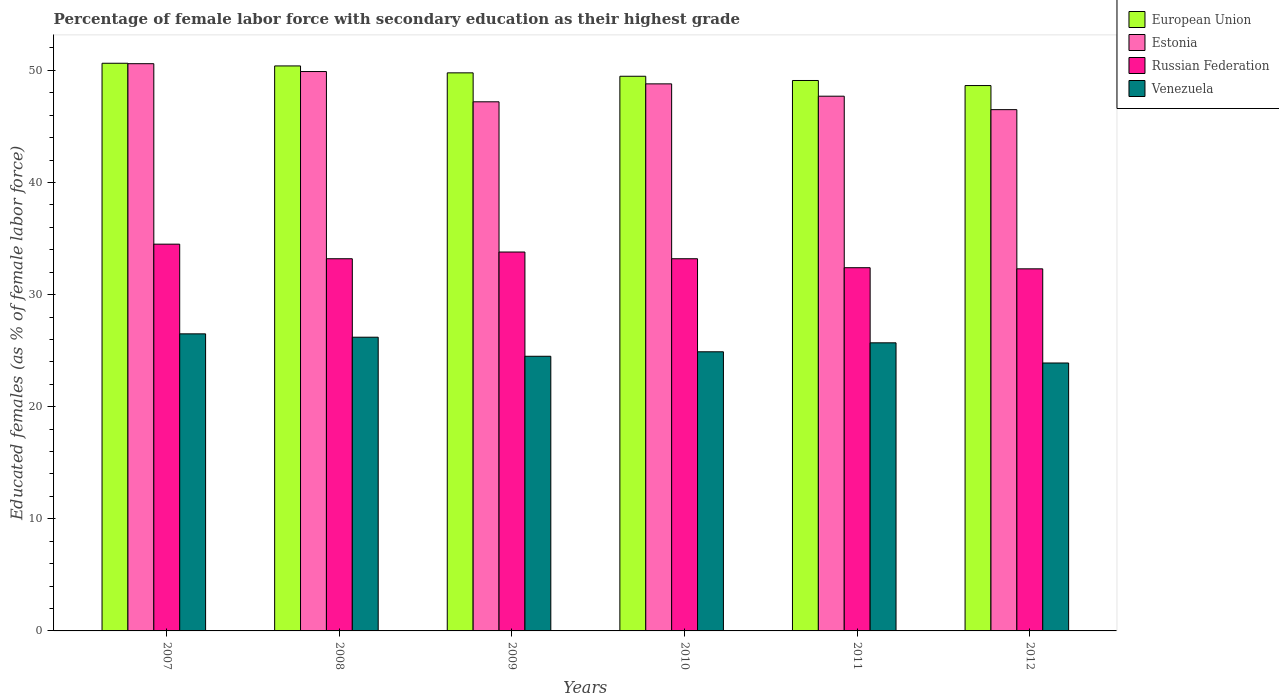How many different coloured bars are there?
Provide a short and direct response. 4. How many groups of bars are there?
Provide a short and direct response. 6. Are the number of bars per tick equal to the number of legend labels?
Your answer should be very brief. Yes. How many bars are there on the 3rd tick from the left?
Your answer should be very brief. 4. What is the label of the 3rd group of bars from the left?
Give a very brief answer. 2009. What is the percentage of female labor force with secondary education in Venezuela in 2009?
Offer a very short reply. 24.5. Across all years, what is the maximum percentage of female labor force with secondary education in European Union?
Offer a very short reply. 50.64. Across all years, what is the minimum percentage of female labor force with secondary education in Venezuela?
Give a very brief answer. 23.9. In which year was the percentage of female labor force with secondary education in Russian Federation maximum?
Ensure brevity in your answer.  2007. In which year was the percentage of female labor force with secondary education in Russian Federation minimum?
Give a very brief answer. 2012. What is the total percentage of female labor force with secondary education in Russian Federation in the graph?
Give a very brief answer. 199.4. What is the difference between the percentage of female labor force with secondary education in European Union in 2008 and that in 2012?
Ensure brevity in your answer.  1.75. What is the difference between the percentage of female labor force with secondary education in Estonia in 2008 and the percentage of female labor force with secondary education in Russian Federation in 2009?
Provide a succinct answer. 16.1. What is the average percentage of female labor force with secondary education in Venezuela per year?
Your response must be concise. 25.28. In the year 2010, what is the difference between the percentage of female labor force with secondary education in European Union and percentage of female labor force with secondary education in Venezuela?
Offer a terse response. 24.58. In how many years, is the percentage of female labor force with secondary education in European Union greater than 24 %?
Ensure brevity in your answer.  6. What is the ratio of the percentage of female labor force with secondary education in Russian Federation in 2009 to that in 2010?
Offer a very short reply. 1.02. Is the percentage of female labor force with secondary education in Venezuela in 2007 less than that in 2011?
Offer a very short reply. No. What is the difference between the highest and the second highest percentage of female labor force with secondary education in Estonia?
Offer a very short reply. 0.7. What is the difference between the highest and the lowest percentage of female labor force with secondary education in European Union?
Ensure brevity in your answer.  1.99. What does the 2nd bar from the left in 2007 represents?
Provide a succinct answer. Estonia. What does the 3rd bar from the right in 2011 represents?
Your response must be concise. Estonia. Is it the case that in every year, the sum of the percentage of female labor force with secondary education in Venezuela and percentage of female labor force with secondary education in European Union is greater than the percentage of female labor force with secondary education in Estonia?
Keep it short and to the point. Yes. How many bars are there?
Provide a succinct answer. 24. Are all the bars in the graph horizontal?
Offer a very short reply. No. How many years are there in the graph?
Your response must be concise. 6. What is the difference between two consecutive major ticks on the Y-axis?
Keep it short and to the point. 10. Does the graph contain any zero values?
Give a very brief answer. No. Does the graph contain grids?
Give a very brief answer. No. How many legend labels are there?
Provide a short and direct response. 4. What is the title of the graph?
Make the answer very short. Percentage of female labor force with secondary education as their highest grade. What is the label or title of the Y-axis?
Your response must be concise. Educated females (as % of female labor force). What is the Educated females (as % of female labor force) of European Union in 2007?
Your answer should be very brief. 50.64. What is the Educated females (as % of female labor force) in Estonia in 2007?
Provide a succinct answer. 50.6. What is the Educated females (as % of female labor force) of Russian Federation in 2007?
Provide a succinct answer. 34.5. What is the Educated females (as % of female labor force) in Venezuela in 2007?
Give a very brief answer. 26.5. What is the Educated females (as % of female labor force) of European Union in 2008?
Offer a terse response. 50.4. What is the Educated females (as % of female labor force) of Estonia in 2008?
Your answer should be compact. 49.9. What is the Educated females (as % of female labor force) in Russian Federation in 2008?
Provide a short and direct response. 33.2. What is the Educated females (as % of female labor force) in Venezuela in 2008?
Provide a short and direct response. 26.2. What is the Educated females (as % of female labor force) in European Union in 2009?
Give a very brief answer. 49.78. What is the Educated females (as % of female labor force) in Estonia in 2009?
Offer a very short reply. 47.2. What is the Educated females (as % of female labor force) of Russian Federation in 2009?
Your response must be concise. 33.8. What is the Educated females (as % of female labor force) of Venezuela in 2009?
Your answer should be compact. 24.5. What is the Educated females (as % of female labor force) of European Union in 2010?
Give a very brief answer. 49.48. What is the Educated females (as % of female labor force) of Estonia in 2010?
Provide a short and direct response. 48.8. What is the Educated females (as % of female labor force) in Russian Federation in 2010?
Provide a short and direct response. 33.2. What is the Educated females (as % of female labor force) of Venezuela in 2010?
Provide a short and direct response. 24.9. What is the Educated females (as % of female labor force) in European Union in 2011?
Offer a very short reply. 49.1. What is the Educated females (as % of female labor force) in Estonia in 2011?
Give a very brief answer. 47.7. What is the Educated females (as % of female labor force) in Russian Federation in 2011?
Give a very brief answer. 32.4. What is the Educated females (as % of female labor force) of Venezuela in 2011?
Offer a very short reply. 25.7. What is the Educated females (as % of female labor force) in European Union in 2012?
Your answer should be compact. 48.65. What is the Educated females (as % of female labor force) of Estonia in 2012?
Offer a terse response. 46.5. What is the Educated females (as % of female labor force) of Russian Federation in 2012?
Provide a succinct answer. 32.3. What is the Educated females (as % of female labor force) in Venezuela in 2012?
Provide a succinct answer. 23.9. Across all years, what is the maximum Educated females (as % of female labor force) in European Union?
Offer a terse response. 50.64. Across all years, what is the maximum Educated females (as % of female labor force) in Estonia?
Keep it short and to the point. 50.6. Across all years, what is the maximum Educated females (as % of female labor force) of Russian Federation?
Offer a terse response. 34.5. Across all years, what is the maximum Educated females (as % of female labor force) in Venezuela?
Give a very brief answer. 26.5. Across all years, what is the minimum Educated females (as % of female labor force) of European Union?
Your response must be concise. 48.65. Across all years, what is the minimum Educated females (as % of female labor force) in Estonia?
Give a very brief answer. 46.5. Across all years, what is the minimum Educated females (as % of female labor force) of Russian Federation?
Provide a short and direct response. 32.3. Across all years, what is the minimum Educated females (as % of female labor force) in Venezuela?
Your answer should be very brief. 23.9. What is the total Educated females (as % of female labor force) of European Union in the graph?
Provide a short and direct response. 298.05. What is the total Educated females (as % of female labor force) of Estonia in the graph?
Make the answer very short. 290.7. What is the total Educated females (as % of female labor force) of Russian Federation in the graph?
Provide a short and direct response. 199.4. What is the total Educated females (as % of female labor force) in Venezuela in the graph?
Your answer should be compact. 151.7. What is the difference between the Educated females (as % of female labor force) of European Union in 2007 and that in 2008?
Provide a short and direct response. 0.24. What is the difference between the Educated females (as % of female labor force) in Russian Federation in 2007 and that in 2008?
Keep it short and to the point. 1.3. What is the difference between the Educated females (as % of female labor force) in European Union in 2007 and that in 2009?
Your answer should be very brief. 0.86. What is the difference between the Educated females (as % of female labor force) in Venezuela in 2007 and that in 2009?
Provide a succinct answer. 2. What is the difference between the Educated females (as % of female labor force) in European Union in 2007 and that in 2010?
Your response must be concise. 1.16. What is the difference between the Educated females (as % of female labor force) in Estonia in 2007 and that in 2010?
Your answer should be compact. 1.8. What is the difference between the Educated females (as % of female labor force) in Russian Federation in 2007 and that in 2010?
Provide a short and direct response. 1.3. What is the difference between the Educated females (as % of female labor force) in European Union in 2007 and that in 2011?
Your response must be concise. 1.54. What is the difference between the Educated females (as % of female labor force) in Estonia in 2007 and that in 2011?
Make the answer very short. 2.9. What is the difference between the Educated females (as % of female labor force) in European Union in 2007 and that in 2012?
Make the answer very short. 1.99. What is the difference between the Educated females (as % of female labor force) in Estonia in 2007 and that in 2012?
Give a very brief answer. 4.1. What is the difference between the Educated females (as % of female labor force) of Russian Federation in 2007 and that in 2012?
Provide a short and direct response. 2.2. What is the difference between the Educated females (as % of female labor force) in European Union in 2008 and that in 2009?
Your response must be concise. 0.62. What is the difference between the Educated females (as % of female labor force) in Russian Federation in 2008 and that in 2009?
Provide a short and direct response. -0.6. What is the difference between the Educated females (as % of female labor force) in Venezuela in 2008 and that in 2009?
Make the answer very short. 1.7. What is the difference between the Educated females (as % of female labor force) in European Union in 2008 and that in 2010?
Offer a very short reply. 0.92. What is the difference between the Educated females (as % of female labor force) of Venezuela in 2008 and that in 2010?
Keep it short and to the point. 1.3. What is the difference between the Educated females (as % of female labor force) in European Union in 2008 and that in 2011?
Keep it short and to the point. 1.3. What is the difference between the Educated females (as % of female labor force) in Estonia in 2008 and that in 2011?
Make the answer very short. 2.2. What is the difference between the Educated females (as % of female labor force) of Venezuela in 2008 and that in 2011?
Keep it short and to the point. 0.5. What is the difference between the Educated females (as % of female labor force) in European Union in 2008 and that in 2012?
Ensure brevity in your answer.  1.75. What is the difference between the Educated females (as % of female labor force) in Russian Federation in 2008 and that in 2012?
Keep it short and to the point. 0.9. What is the difference between the Educated females (as % of female labor force) in Venezuela in 2008 and that in 2012?
Make the answer very short. 2.3. What is the difference between the Educated females (as % of female labor force) in European Union in 2009 and that in 2010?
Offer a terse response. 0.3. What is the difference between the Educated females (as % of female labor force) of Estonia in 2009 and that in 2010?
Your answer should be compact. -1.6. What is the difference between the Educated females (as % of female labor force) in Venezuela in 2009 and that in 2010?
Your answer should be compact. -0.4. What is the difference between the Educated females (as % of female labor force) in European Union in 2009 and that in 2011?
Make the answer very short. 0.68. What is the difference between the Educated females (as % of female labor force) in Venezuela in 2009 and that in 2011?
Keep it short and to the point. -1.2. What is the difference between the Educated females (as % of female labor force) of European Union in 2009 and that in 2012?
Provide a short and direct response. 1.13. What is the difference between the Educated females (as % of female labor force) in Estonia in 2009 and that in 2012?
Provide a succinct answer. 0.7. What is the difference between the Educated females (as % of female labor force) of European Union in 2010 and that in 2011?
Keep it short and to the point. 0.38. What is the difference between the Educated females (as % of female labor force) of European Union in 2010 and that in 2012?
Make the answer very short. 0.83. What is the difference between the Educated females (as % of female labor force) of European Union in 2011 and that in 2012?
Keep it short and to the point. 0.45. What is the difference between the Educated females (as % of female labor force) in Russian Federation in 2011 and that in 2012?
Provide a succinct answer. 0.1. What is the difference between the Educated females (as % of female labor force) in European Union in 2007 and the Educated females (as % of female labor force) in Estonia in 2008?
Your answer should be compact. 0.74. What is the difference between the Educated females (as % of female labor force) of European Union in 2007 and the Educated females (as % of female labor force) of Russian Federation in 2008?
Provide a succinct answer. 17.44. What is the difference between the Educated females (as % of female labor force) of European Union in 2007 and the Educated females (as % of female labor force) of Venezuela in 2008?
Provide a succinct answer. 24.44. What is the difference between the Educated females (as % of female labor force) in Estonia in 2007 and the Educated females (as % of female labor force) in Russian Federation in 2008?
Your answer should be compact. 17.4. What is the difference between the Educated females (as % of female labor force) in Estonia in 2007 and the Educated females (as % of female labor force) in Venezuela in 2008?
Provide a short and direct response. 24.4. What is the difference between the Educated females (as % of female labor force) in Russian Federation in 2007 and the Educated females (as % of female labor force) in Venezuela in 2008?
Your answer should be compact. 8.3. What is the difference between the Educated females (as % of female labor force) of European Union in 2007 and the Educated females (as % of female labor force) of Estonia in 2009?
Your answer should be very brief. 3.44. What is the difference between the Educated females (as % of female labor force) of European Union in 2007 and the Educated females (as % of female labor force) of Russian Federation in 2009?
Offer a terse response. 16.84. What is the difference between the Educated females (as % of female labor force) in European Union in 2007 and the Educated females (as % of female labor force) in Venezuela in 2009?
Ensure brevity in your answer.  26.14. What is the difference between the Educated females (as % of female labor force) in Estonia in 2007 and the Educated females (as % of female labor force) in Venezuela in 2009?
Your response must be concise. 26.1. What is the difference between the Educated females (as % of female labor force) in Russian Federation in 2007 and the Educated females (as % of female labor force) in Venezuela in 2009?
Give a very brief answer. 10. What is the difference between the Educated females (as % of female labor force) of European Union in 2007 and the Educated females (as % of female labor force) of Estonia in 2010?
Give a very brief answer. 1.84. What is the difference between the Educated females (as % of female labor force) of European Union in 2007 and the Educated females (as % of female labor force) of Russian Federation in 2010?
Your answer should be compact. 17.44. What is the difference between the Educated females (as % of female labor force) of European Union in 2007 and the Educated females (as % of female labor force) of Venezuela in 2010?
Provide a succinct answer. 25.74. What is the difference between the Educated females (as % of female labor force) of Estonia in 2007 and the Educated females (as % of female labor force) of Venezuela in 2010?
Your response must be concise. 25.7. What is the difference between the Educated females (as % of female labor force) of Russian Federation in 2007 and the Educated females (as % of female labor force) of Venezuela in 2010?
Your response must be concise. 9.6. What is the difference between the Educated females (as % of female labor force) of European Union in 2007 and the Educated females (as % of female labor force) of Estonia in 2011?
Your answer should be compact. 2.94. What is the difference between the Educated females (as % of female labor force) in European Union in 2007 and the Educated females (as % of female labor force) in Russian Federation in 2011?
Your response must be concise. 18.24. What is the difference between the Educated females (as % of female labor force) in European Union in 2007 and the Educated females (as % of female labor force) in Venezuela in 2011?
Offer a very short reply. 24.94. What is the difference between the Educated females (as % of female labor force) in Estonia in 2007 and the Educated females (as % of female labor force) in Russian Federation in 2011?
Keep it short and to the point. 18.2. What is the difference between the Educated females (as % of female labor force) in Estonia in 2007 and the Educated females (as % of female labor force) in Venezuela in 2011?
Provide a short and direct response. 24.9. What is the difference between the Educated females (as % of female labor force) of European Union in 2007 and the Educated females (as % of female labor force) of Estonia in 2012?
Provide a succinct answer. 4.14. What is the difference between the Educated females (as % of female labor force) in European Union in 2007 and the Educated females (as % of female labor force) in Russian Federation in 2012?
Your answer should be compact. 18.34. What is the difference between the Educated females (as % of female labor force) in European Union in 2007 and the Educated females (as % of female labor force) in Venezuela in 2012?
Your response must be concise. 26.74. What is the difference between the Educated females (as % of female labor force) in Estonia in 2007 and the Educated females (as % of female labor force) in Venezuela in 2012?
Provide a succinct answer. 26.7. What is the difference between the Educated females (as % of female labor force) in European Union in 2008 and the Educated females (as % of female labor force) in Venezuela in 2009?
Your answer should be very brief. 25.9. What is the difference between the Educated females (as % of female labor force) of Estonia in 2008 and the Educated females (as % of female labor force) of Venezuela in 2009?
Ensure brevity in your answer.  25.4. What is the difference between the Educated females (as % of female labor force) of Russian Federation in 2008 and the Educated females (as % of female labor force) of Venezuela in 2009?
Provide a succinct answer. 8.7. What is the difference between the Educated females (as % of female labor force) of European Union in 2008 and the Educated females (as % of female labor force) of Estonia in 2010?
Offer a very short reply. 1.6. What is the difference between the Educated females (as % of female labor force) in European Union in 2008 and the Educated females (as % of female labor force) in Russian Federation in 2010?
Provide a short and direct response. 17.2. What is the difference between the Educated females (as % of female labor force) of European Union in 2008 and the Educated females (as % of female labor force) of Venezuela in 2010?
Your answer should be very brief. 25.5. What is the difference between the Educated females (as % of female labor force) in European Union in 2008 and the Educated females (as % of female labor force) in Venezuela in 2011?
Your response must be concise. 24.7. What is the difference between the Educated females (as % of female labor force) in Estonia in 2008 and the Educated females (as % of female labor force) in Venezuela in 2011?
Your answer should be compact. 24.2. What is the difference between the Educated females (as % of female labor force) in Russian Federation in 2008 and the Educated females (as % of female labor force) in Venezuela in 2011?
Your response must be concise. 7.5. What is the difference between the Educated females (as % of female labor force) of European Union in 2008 and the Educated females (as % of female labor force) of Estonia in 2012?
Offer a terse response. 3.9. What is the difference between the Educated females (as % of female labor force) of European Union in 2008 and the Educated females (as % of female labor force) of Russian Federation in 2012?
Give a very brief answer. 18.1. What is the difference between the Educated females (as % of female labor force) of Estonia in 2008 and the Educated females (as % of female labor force) of Russian Federation in 2012?
Your answer should be very brief. 17.6. What is the difference between the Educated females (as % of female labor force) of Russian Federation in 2008 and the Educated females (as % of female labor force) of Venezuela in 2012?
Offer a very short reply. 9.3. What is the difference between the Educated females (as % of female labor force) in European Union in 2009 and the Educated females (as % of female labor force) in Estonia in 2010?
Offer a terse response. 0.98. What is the difference between the Educated females (as % of female labor force) of European Union in 2009 and the Educated females (as % of female labor force) of Russian Federation in 2010?
Give a very brief answer. 16.58. What is the difference between the Educated females (as % of female labor force) of European Union in 2009 and the Educated females (as % of female labor force) of Venezuela in 2010?
Provide a short and direct response. 24.88. What is the difference between the Educated females (as % of female labor force) in Estonia in 2009 and the Educated females (as % of female labor force) in Russian Federation in 2010?
Keep it short and to the point. 14. What is the difference between the Educated females (as % of female labor force) in Estonia in 2009 and the Educated females (as % of female labor force) in Venezuela in 2010?
Provide a short and direct response. 22.3. What is the difference between the Educated females (as % of female labor force) of European Union in 2009 and the Educated females (as % of female labor force) of Estonia in 2011?
Offer a very short reply. 2.08. What is the difference between the Educated females (as % of female labor force) of European Union in 2009 and the Educated females (as % of female labor force) of Russian Federation in 2011?
Ensure brevity in your answer.  17.38. What is the difference between the Educated females (as % of female labor force) in European Union in 2009 and the Educated females (as % of female labor force) in Venezuela in 2011?
Ensure brevity in your answer.  24.08. What is the difference between the Educated females (as % of female labor force) of Estonia in 2009 and the Educated females (as % of female labor force) of Venezuela in 2011?
Offer a terse response. 21.5. What is the difference between the Educated females (as % of female labor force) in Russian Federation in 2009 and the Educated females (as % of female labor force) in Venezuela in 2011?
Offer a terse response. 8.1. What is the difference between the Educated females (as % of female labor force) of European Union in 2009 and the Educated females (as % of female labor force) of Estonia in 2012?
Provide a short and direct response. 3.28. What is the difference between the Educated females (as % of female labor force) in European Union in 2009 and the Educated females (as % of female labor force) in Russian Federation in 2012?
Your response must be concise. 17.48. What is the difference between the Educated females (as % of female labor force) of European Union in 2009 and the Educated females (as % of female labor force) of Venezuela in 2012?
Ensure brevity in your answer.  25.88. What is the difference between the Educated females (as % of female labor force) of Estonia in 2009 and the Educated females (as % of female labor force) of Venezuela in 2012?
Provide a short and direct response. 23.3. What is the difference between the Educated females (as % of female labor force) of Russian Federation in 2009 and the Educated females (as % of female labor force) of Venezuela in 2012?
Provide a succinct answer. 9.9. What is the difference between the Educated females (as % of female labor force) of European Union in 2010 and the Educated females (as % of female labor force) of Estonia in 2011?
Ensure brevity in your answer.  1.78. What is the difference between the Educated females (as % of female labor force) of European Union in 2010 and the Educated females (as % of female labor force) of Russian Federation in 2011?
Make the answer very short. 17.08. What is the difference between the Educated females (as % of female labor force) in European Union in 2010 and the Educated females (as % of female labor force) in Venezuela in 2011?
Give a very brief answer. 23.78. What is the difference between the Educated females (as % of female labor force) in Estonia in 2010 and the Educated females (as % of female labor force) in Venezuela in 2011?
Offer a very short reply. 23.1. What is the difference between the Educated females (as % of female labor force) of Russian Federation in 2010 and the Educated females (as % of female labor force) of Venezuela in 2011?
Your answer should be compact. 7.5. What is the difference between the Educated females (as % of female labor force) of European Union in 2010 and the Educated females (as % of female labor force) of Estonia in 2012?
Provide a short and direct response. 2.98. What is the difference between the Educated females (as % of female labor force) of European Union in 2010 and the Educated females (as % of female labor force) of Russian Federation in 2012?
Your response must be concise. 17.18. What is the difference between the Educated females (as % of female labor force) in European Union in 2010 and the Educated females (as % of female labor force) in Venezuela in 2012?
Keep it short and to the point. 25.58. What is the difference between the Educated females (as % of female labor force) of Estonia in 2010 and the Educated females (as % of female labor force) of Russian Federation in 2012?
Keep it short and to the point. 16.5. What is the difference between the Educated females (as % of female labor force) in Estonia in 2010 and the Educated females (as % of female labor force) in Venezuela in 2012?
Offer a terse response. 24.9. What is the difference between the Educated females (as % of female labor force) in Russian Federation in 2010 and the Educated females (as % of female labor force) in Venezuela in 2012?
Offer a terse response. 9.3. What is the difference between the Educated females (as % of female labor force) in European Union in 2011 and the Educated females (as % of female labor force) in Estonia in 2012?
Your answer should be compact. 2.6. What is the difference between the Educated females (as % of female labor force) in European Union in 2011 and the Educated females (as % of female labor force) in Russian Federation in 2012?
Offer a very short reply. 16.8. What is the difference between the Educated females (as % of female labor force) in European Union in 2011 and the Educated females (as % of female labor force) in Venezuela in 2012?
Offer a very short reply. 25.2. What is the difference between the Educated females (as % of female labor force) of Estonia in 2011 and the Educated females (as % of female labor force) of Russian Federation in 2012?
Make the answer very short. 15.4. What is the difference between the Educated females (as % of female labor force) in Estonia in 2011 and the Educated females (as % of female labor force) in Venezuela in 2012?
Keep it short and to the point. 23.8. What is the average Educated females (as % of female labor force) of European Union per year?
Make the answer very short. 49.67. What is the average Educated females (as % of female labor force) in Estonia per year?
Offer a very short reply. 48.45. What is the average Educated females (as % of female labor force) of Russian Federation per year?
Ensure brevity in your answer.  33.23. What is the average Educated females (as % of female labor force) in Venezuela per year?
Offer a terse response. 25.28. In the year 2007, what is the difference between the Educated females (as % of female labor force) of European Union and Educated females (as % of female labor force) of Estonia?
Offer a terse response. 0.04. In the year 2007, what is the difference between the Educated females (as % of female labor force) of European Union and Educated females (as % of female labor force) of Russian Federation?
Give a very brief answer. 16.14. In the year 2007, what is the difference between the Educated females (as % of female labor force) in European Union and Educated females (as % of female labor force) in Venezuela?
Ensure brevity in your answer.  24.14. In the year 2007, what is the difference between the Educated females (as % of female labor force) of Estonia and Educated females (as % of female labor force) of Venezuela?
Ensure brevity in your answer.  24.1. In the year 2007, what is the difference between the Educated females (as % of female labor force) of Russian Federation and Educated females (as % of female labor force) of Venezuela?
Provide a succinct answer. 8. In the year 2008, what is the difference between the Educated females (as % of female labor force) in European Union and Educated females (as % of female labor force) in Russian Federation?
Provide a succinct answer. 17.2. In the year 2008, what is the difference between the Educated females (as % of female labor force) in European Union and Educated females (as % of female labor force) in Venezuela?
Offer a very short reply. 24.2. In the year 2008, what is the difference between the Educated females (as % of female labor force) in Estonia and Educated females (as % of female labor force) in Venezuela?
Offer a very short reply. 23.7. In the year 2008, what is the difference between the Educated females (as % of female labor force) of Russian Federation and Educated females (as % of female labor force) of Venezuela?
Provide a short and direct response. 7. In the year 2009, what is the difference between the Educated females (as % of female labor force) of European Union and Educated females (as % of female labor force) of Estonia?
Offer a terse response. 2.58. In the year 2009, what is the difference between the Educated females (as % of female labor force) of European Union and Educated females (as % of female labor force) of Russian Federation?
Ensure brevity in your answer.  15.98. In the year 2009, what is the difference between the Educated females (as % of female labor force) in European Union and Educated females (as % of female labor force) in Venezuela?
Your answer should be compact. 25.28. In the year 2009, what is the difference between the Educated females (as % of female labor force) in Estonia and Educated females (as % of female labor force) in Russian Federation?
Give a very brief answer. 13.4. In the year 2009, what is the difference between the Educated females (as % of female labor force) in Estonia and Educated females (as % of female labor force) in Venezuela?
Ensure brevity in your answer.  22.7. In the year 2010, what is the difference between the Educated females (as % of female labor force) of European Union and Educated females (as % of female labor force) of Estonia?
Keep it short and to the point. 0.68. In the year 2010, what is the difference between the Educated females (as % of female labor force) in European Union and Educated females (as % of female labor force) in Russian Federation?
Make the answer very short. 16.28. In the year 2010, what is the difference between the Educated females (as % of female labor force) in European Union and Educated females (as % of female labor force) in Venezuela?
Your answer should be very brief. 24.58. In the year 2010, what is the difference between the Educated females (as % of female labor force) in Estonia and Educated females (as % of female labor force) in Russian Federation?
Your response must be concise. 15.6. In the year 2010, what is the difference between the Educated females (as % of female labor force) of Estonia and Educated females (as % of female labor force) of Venezuela?
Ensure brevity in your answer.  23.9. In the year 2010, what is the difference between the Educated females (as % of female labor force) of Russian Federation and Educated females (as % of female labor force) of Venezuela?
Your response must be concise. 8.3. In the year 2011, what is the difference between the Educated females (as % of female labor force) of European Union and Educated females (as % of female labor force) of Estonia?
Make the answer very short. 1.4. In the year 2011, what is the difference between the Educated females (as % of female labor force) in European Union and Educated females (as % of female labor force) in Russian Federation?
Provide a succinct answer. 16.7. In the year 2011, what is the difference between the Educated females (as % of female labor force) in European Union and Educated females (as % of female labor force) in Venezuela?
Ensure brevity in your answer.  23.4. In the year 2011, what is the difference between the Educated females (as % of female labor force) of Estonia and Educated females (as % of female labor force) of Venezuela?
Your response must be concise. 22. In the year 2011, what is the difference between the Educated females (as % of female labor force) of Russian Federation and Educated females (as % of female labor force) of Venezuela?
Give a very brief answer. 6.7. In the year 2012, what is the difference between the Educated females (as % of female labor force) of European Union and Educated females (as % of female labor force) of Estonia?
Ensure brevity in your answer.  2.15. In the year 2012, what is the difference between the Educated females (as % of female labor force) in European Union and Educated females (as % of female labor force) in Russian Federation?
Keep it short and to the point. 16.35. In the year 2012, what is the difference between the Educated females (as % of female labor force) in European Union and Educated females (as % of female labor force) in Venezuela?
Your response must be concise. 24.75. In the year 2012, what is the difference between the Educated females (as % of female labor force) in Estonia and Educated females (as % of female labor force) in Venezuela?
Your response must be concise. 22.6. In the year 2012, what is the difference between the Educated females (as % of female labor force) of Russian Federation and Educated females (as % of female labor force) of Venezuela?
Your answer should be compact. 8.4. What is the ratio of the Educated females (as % of female labor force) in European Union in 2007 to that in 2008?
Offer a very short reply. 1. What is the ratio of the Educated females (as % of female labor force) of Estonia in 2007 to that in 2008?
Your answer should be compact. 1.01. What is the ratio of the Educated females (as % of female labor force) in Russian Federation in 2007 to that in 2008?
Your answer should be very brief. 1.04. What is the ratio of the Educated females (as % of female labor force) of Venezuela in 2007 to that in 2008?
Your response must be concise. 1.01. What is the ratio of the Educated females (as % of female labor force) in European Union in 2007 to that in 2009?
Make the answer very short. 1.02. What is the ratio of the Educated females (as % of female labor force) in Estonia in 2007 to that in 2009?
Make the answer very short. 1.07. What is the ratio of the Educated females (as % of female labor force) in Russian Federation in 2007 to that in 2009?
Keep it short and to the point. 1.02. What is the ratio of the Educated females (as % of female labor force) of Venezuela in 2007 to that in 2009?
Provide a succinct answer. 1.08. What is the ratio of the Educated females (as % of female labor force) of European Union in 2007 to that in 2010?
Provide a short and direct response. 1.02. What is the ratio of the Educated females (as % of female labor force) of Estonia in 2007 to that in 2010?
Make the answer very short. 1.04. What is the ratio of the Educated females (as % of female labor force) in Russian Federation in 2007 to that in 2010?
Offer a terse response. 1.04. What is the ratio of the Educated females (as % of female labor force) in Venezuela in 2007 to that in 2010?
Provide a short and direct response. 1.06. What is the ratio of the Educated females (as % of female labor force) in European Union in 2007 to that in 2011?
Give a very brief answer. 1.03. What is the ratio of the Educated females (as % of female labor force) in Estonia in 2007 to that in 2011?
Your answer should be very brief. 1.06. What is the ratio of the Educated females (as % of female labor force) in Russian Federation in 2007 to that in 2011?
Give a very brief answer. 1.06. What is the ratio of the Educated females (as % of female labor force) of Venezuela in 2007 to that in 2011?
Your answer should be very brief. 1.03. What is the ratio of the Educated females (as % of female labor force) of European Union in 2007 to that in 2012?
Your response must be concise. 1.04. What is the ratio of the Educated females (as % of female labor force) in Estonia in 2007 to that in 2012?
Keep it short and to the point. 1.09. What is the ratio of the Educated females (as % of female labor force) of Russian Federation in 2007 to that in 2012?
Give a very brief answer. 1.07. What is the ratio of the Educated females (as % of female labor force) in Venezuela in 2007 to that in 2012?
Offer a very short reply. 1.11. What is the ratio of the Educated females (as % of female labor force) in European Union in 2008 to that in 2009?
Your answer should be compact. 1.01. What is the ratio of the Educated females (as % of female labor force) of Estonia in 2008 to that in 2009?
Keep it short and to the point. 1.06. What is the ratio of the Educated females (as % of female labor force) of Russian Federation in 2008 to that in 2009?
Provide a succinct answer. 0.98. What is the ratio of the Educated females (as % of female labor force) of Venezuela in 2008 to that in 2009?
Your answer should be compact. 1.07. What is the ratio of the Educated females (as % of female labor force) in European Union in 2008 to that in 2010?
Provide a short and direct response. 1.02. What is the ratio of the Educated females (as % of female labor force) of Estonia in 2008 to that in 2010?
Keep it short and to the point. 1.02. What is the ratio of the Educated females (as % of female labor force) of Russian Federation in 2008 to that in 2010?
Provide a succinct answer. 1. What is the ratio of the Educated females (as % of female labor force) in Venezuela in 2008 to that in 2010?
Your response must be concise. 1.05. What is the ratio of the Educated females (as % of female labor force) of European Union in 2008 to that in 2011?
Make the answer very short. 1.03. What is the ratio of the Educated females (as % of female labor force) in Estonia in 2008 to that in 2011?
Provide a succinct answer. 1.05. What is the ratio of the Educated females (as % of female labor force) in Russian Federation in 2008 to that in 2011?
Provide a succinct answer. 1.02. What is the ratio of the Educated females (as % of female labor force) in Venezuela in 2008 to that in 2011?
Your answer should be compact. 1.02. What is the ratio of the Educated females (as % of female labor force) of European Union in 2008 to that in 2012?
Provide a short and direct response. 1.04. What is the ratio of the Educated females (as % of female labor force) in Estonia in 2008 to that in 2012?
Ensure brevity in your answer.  1.07. What is the ratio of the Educated females (as % of female labor force) in Russian Federation in 2008 to that in 2012?
Your answer should be very brief. 1.03. What is the ratio of the Educated females (as % of female labor force) in Venezuela in 2008 to that in 2012?
Give a very brief answer. 1.1. What is the ratio of the Educated females (as % of female labor force) in European Union in 2009 to that in 2010?
Your answer should be very brief. 1.01. What is the ratio of the Educated females (as % of female labor force) in Estonia in 2009 to that in 2010?
Keep it short and to the point. 0.97. What is the ratio of the Educated females (as % of female labor force) in Russian Federation in 2009 to that in 2010?
Your answer should be very brief. 1.02. What is the ratio of the Educated females (as % of female labor force) of Venezuela in 2009 to that in 2010?
Ensure brevity in your answer.  0.98. What is the ratio of the Educated females (as % of female labor force) of European Union in 2009 to that in 2011?
Offer a terse response. 1.01. What is the ratio of the Educated females (as % of female labor force) of Russian Federation in 2009 to that in 2011?
Your response must be concise. 1.04. What is the ratio of the Educated females (as % of female labor force) in Venezuela in 2009 to that in 2011?
Your answer should be compact. 0.95. What is the ratio of the Educated females (as % of female labor force) in European Union in 2009 to that in 2012?
Offer a very short reply. 1.02. What is the ratio of the Educated females (as % of female labor force) of Estonia in 2009 to that in 2012?
Ensure brevity in your answer.  1.02. What is the ratio of the Educated females (as % of female labor force) in Russian Federation in 2009 to that in 2012?
Your answer should be compact. 1.05. What is the ratio of the Educated females (as % of female labor force) of Venezuela in 2009 to that in 2012?
Keep it short and to the point. 1.03. What is the ratio of the Educated females (as % of female labor force) in European Union in 2010 to that in 2011?
Make the answer very short. 1.01. What is the ratio of the Educated females (as % of female labor force) of Estonia in 2010 to that in 2011?
Provide a succinct answer. 1.02. What is the ratio of the Educated females (as % of female labor force) of Russian Federation in 2010 to that in 2011?
Offer a terse response. 1.02. What is the ratio of the Educated females (as % of female labor force) of Venezuela in 2010 to that in 2011?
Provide a short and direct response. 0.97. What is the ratio of the Educated females (as % of female labor force) in European Union in 2010 to that in 2012?
Keep it short and to the point. 1.02. What is the ratio of the Educated females (as % of female labor force) of Estonia in 2010 to that in 2012?
Offer a very short reply. 1.05. What is the ratio of the Educated females (as % of female labor force) of Russian Federation in 2010 to that in 2012?
Offer a terse response. 1.03. What is the ratio of the Educated females (as % of female labor force) in Venezuela in 2010 to that in 2012?
Offer a terse response. 1.04. What is the ratio of the Educated females (as % of female labor force) in European Union in 2011 to that in 2012?
Your answer should be very brief. 1.01. What is the ratio of the Educated females (as % of female labor force) in Estonia in 2011 to that in 2012?
Ensure brevity in your answer.  1.03. What is the ratio of the Educated females (as % of female labor force) of Venezuela in 2011 to that in 2012?
Offer a very short reply. 1.08. What is the difference between the highest and the second highest Educated females (as % of female labor force) in European Union?
Provide a succinct answer. 0.24. What is the difference between the highest and the second highest Educated females (as % of female labor force) in Russian Federation?
Ensure brevity in your answer.  0.7. What is the difference between the highest and the second highest Educated females (as % of female labor force) of Venezuela?
Your answer should be very brief. 0.3. What is the difference between the highest and the lowest Educated females (as % of female labor force) of European Union?
Ensure brevity in your answer.  1.99. What is the difference between the highest and the lowest Educated females (as % of female labor force) in Estonia?
Ensure brevity in your answer.  4.1. What is the difference between the highest and the lowest Educated females (as % of female labor force) in Venezuela?
Offer a terse response. 2.6. 